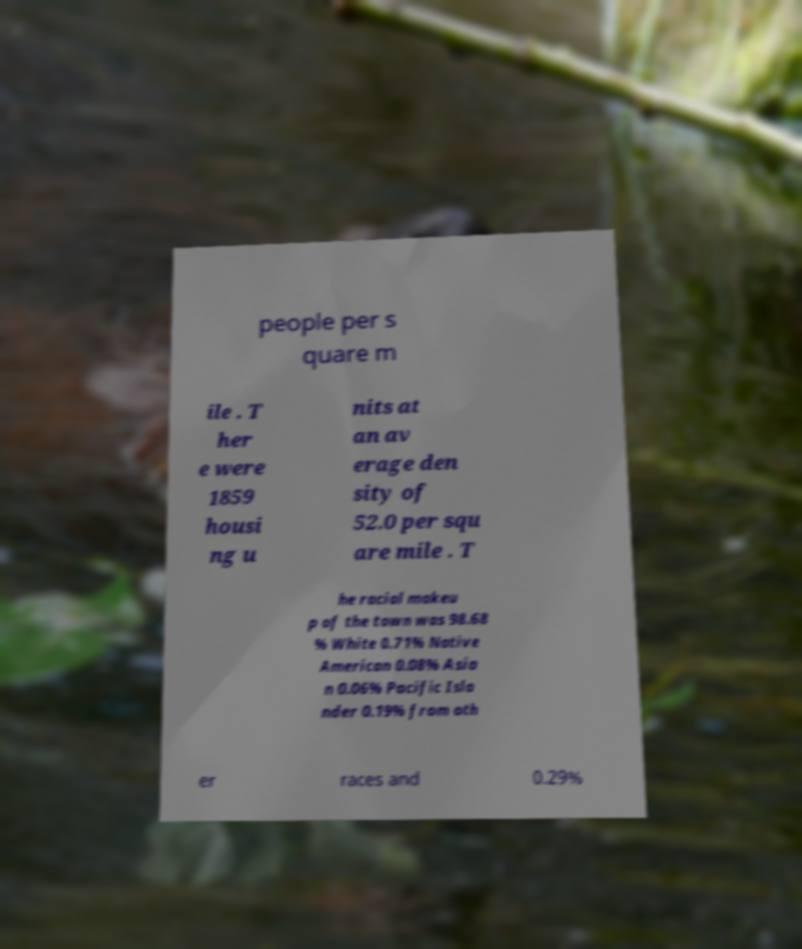Please read and relay the text visible in this image. What does it say? people per s quare m ile . T her e were 1859 housi ng u nits at an av erage den sity of 52.0 per squ are mile . T he racial makeu p of the town was 98.68 % White 0.71% Native American 0.08% Asia n 0.06% Pacific Isla nder 0.19% from oth er races and 0.29% 